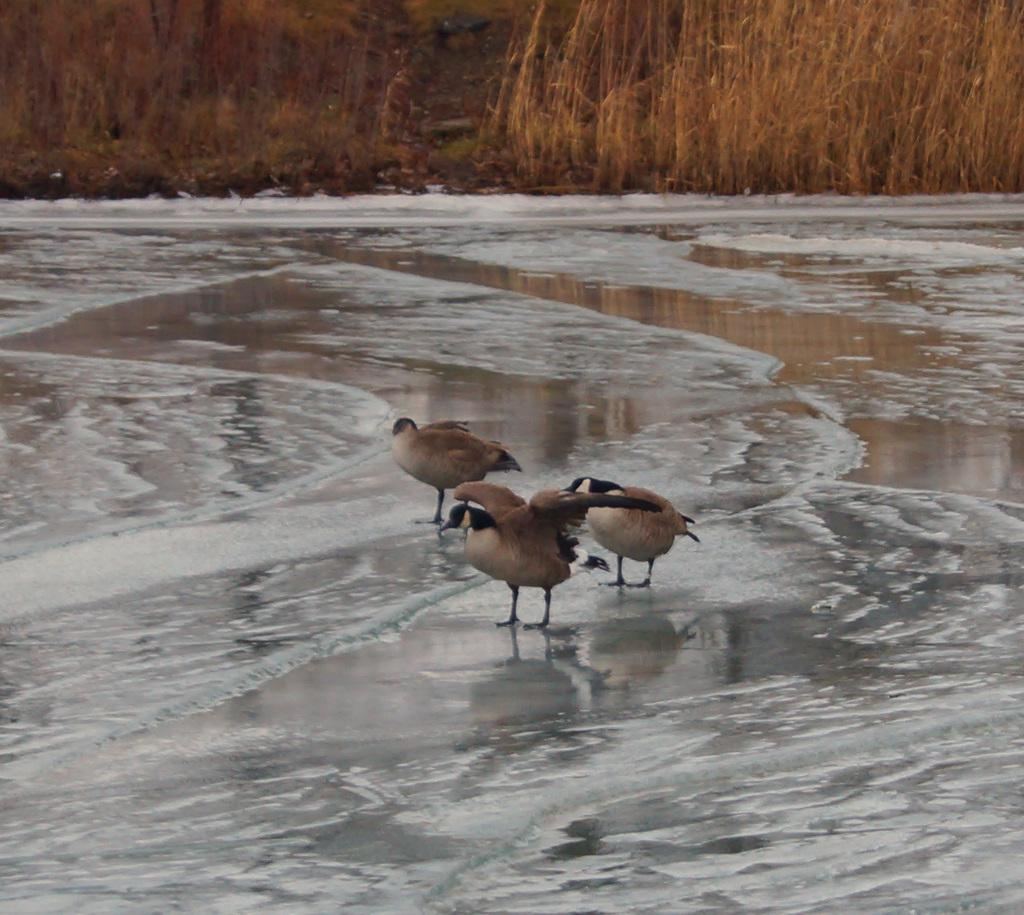What type of animals can be seen in the image? Birds can be seen in the image. What is the primary element in which the birds are situated? The birds are situated in water. What can be seen in the background of the image? There is dry grass in the background of the image. What memory is the boy recalling in the image? There are no boys present in the image, so it is not possible to determine what memory they might be recalling. 